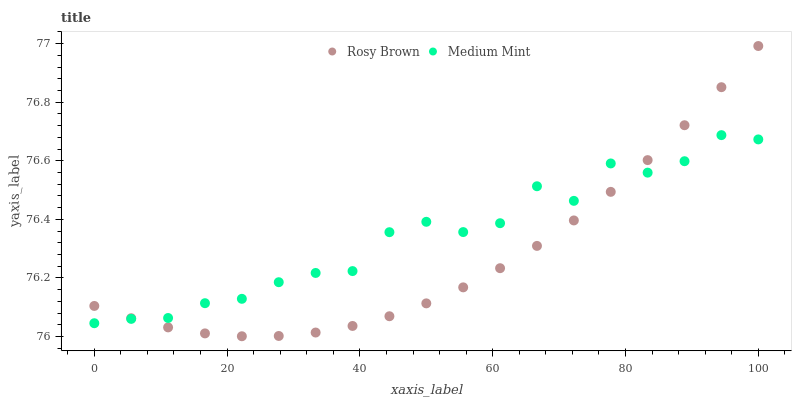Does Rosy Brown have the minimum area under the curve?
Answer yes or no. Yes. Does Medium Mint have the maximum area under the curve?
Answer yes or no. Yes. Does Rosy Brown have the maximum area under the curve?
Answer yes or no. No. Is Rosy Brown the smoothest?
Answer yes or no. Yes. Is Medium Mint the roughest?
Answer yes or no. Yes. Is Rosy Brown the roughest?
Answer yes or no. No. Does Rosy Brown have the lowest value?
Answer yes or no. Yes. Does Rosy Brown have the highest value?
Answer yes or no. Yes. Does Medium Mint intersect Rosy Brown?
Answer yes or no. Yes. Is Medium Mint less than Rosy Brown?
Answer yes or no. No. Is Medium Mint greater than Rosy Brown?
Answer yes or no. No. 